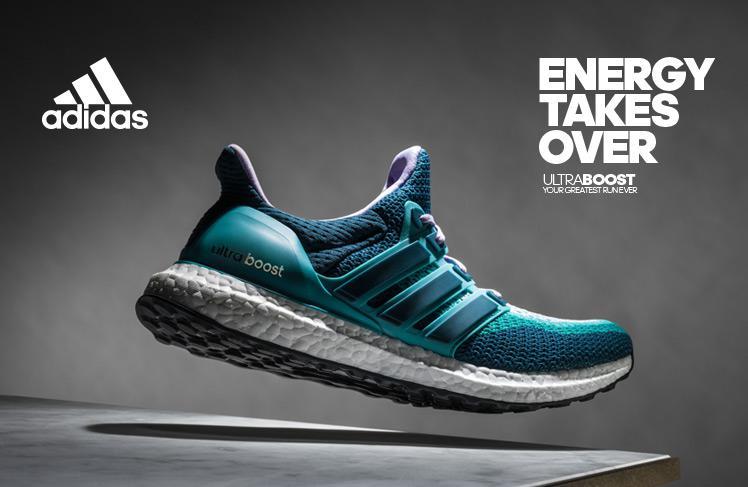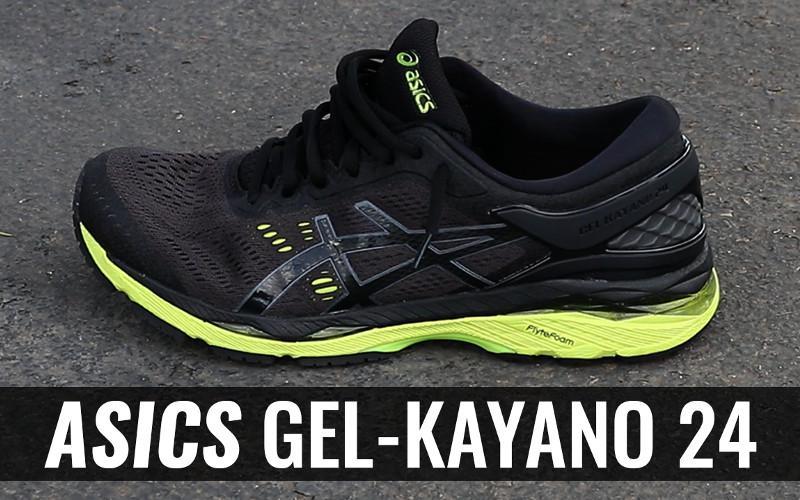The first image is the image on the left, the second image is the image on the right. Given the left and right images, does the statement "The left image is a blue shoe on a white background." hold true? Answer yes or no. No. 